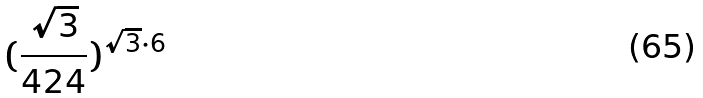Convert formula to latex. <formula><loc_0><loc_0><loc_500><loc_500>( \frac { \sqrt { 3 } } { 4 2 4 } ) ^ { \sqrt { 3 } \cdot 6 }</formula> 